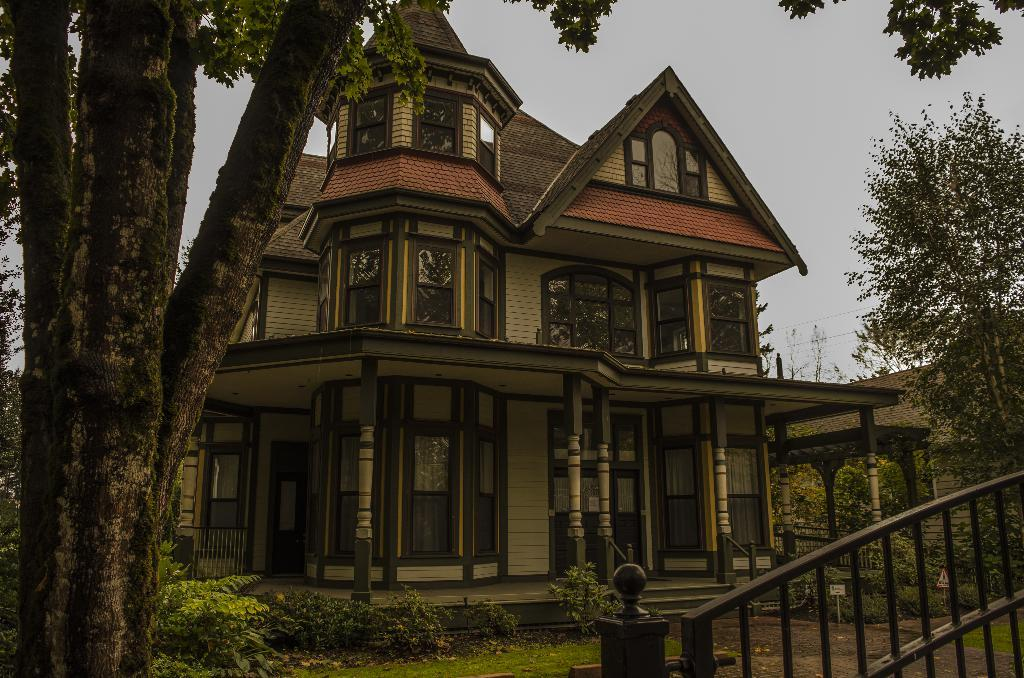What type of structure is present in the image? There is a house in the image. What other natural elements can be seen in the image? There are trees in the image. What is visible in the background of the image? The sky is visible in the image. How can one access the house in the image? There is an entrance gate to the house in the image. What type of silver item can be seen in the image? There is no silver item present in the image. Can you find a receipt for the house in the image? There is no receipt visible in the image, as it is a photograph of a house and not a transaction record. 